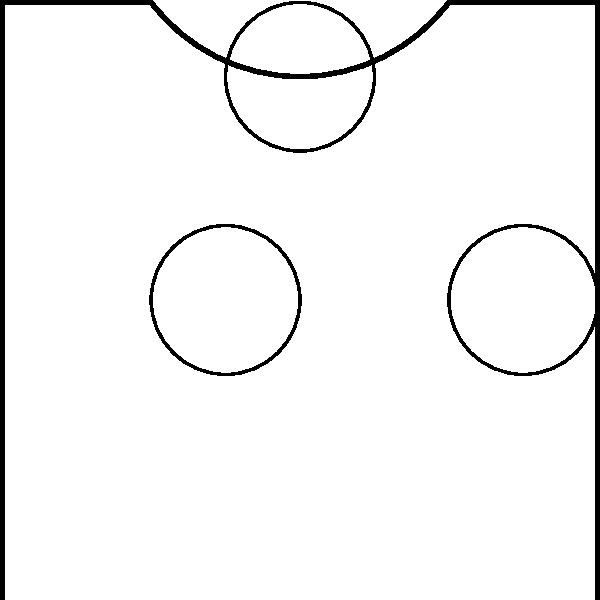As you float through the misty air of a historic cemetery, you encounter an intricate wrought-iron gate with ornate patterns. The gate exhibits line symmetry. If the line of reflection is the ground level, what transformation would map the point $(1, 2)$ on the original gate to its corresponding point on the reflected image? To solve this problem, let's follow these steps:

1) First, recall that in a line reflection, each point is mapped to a point that is equidistant from the line of reflection, but on the opposite side.

2) The line of reflection in this case is the ground level, which we can consider as the x-axis (y = 0).

3) For a reflection over the x-axis, the general transformation is:
   $$(x, y) \rightarrow (x, -y)$$

4) The original point is given as $(1, 2)$.

5) Applying the transformation:
   $(1, 2) \rightarrow (1, -2)$

6) This transformation can be described as a reflection over the x-axis, or equivalently, a reflection in the line $y = 0$.

Therefore, the transformation that maps $(1, 2)$ to its corresponding point on the reflected image is a reflection over the x-axis (or the line $y = 0$).
Answer: Reflection over $y = 0$ 